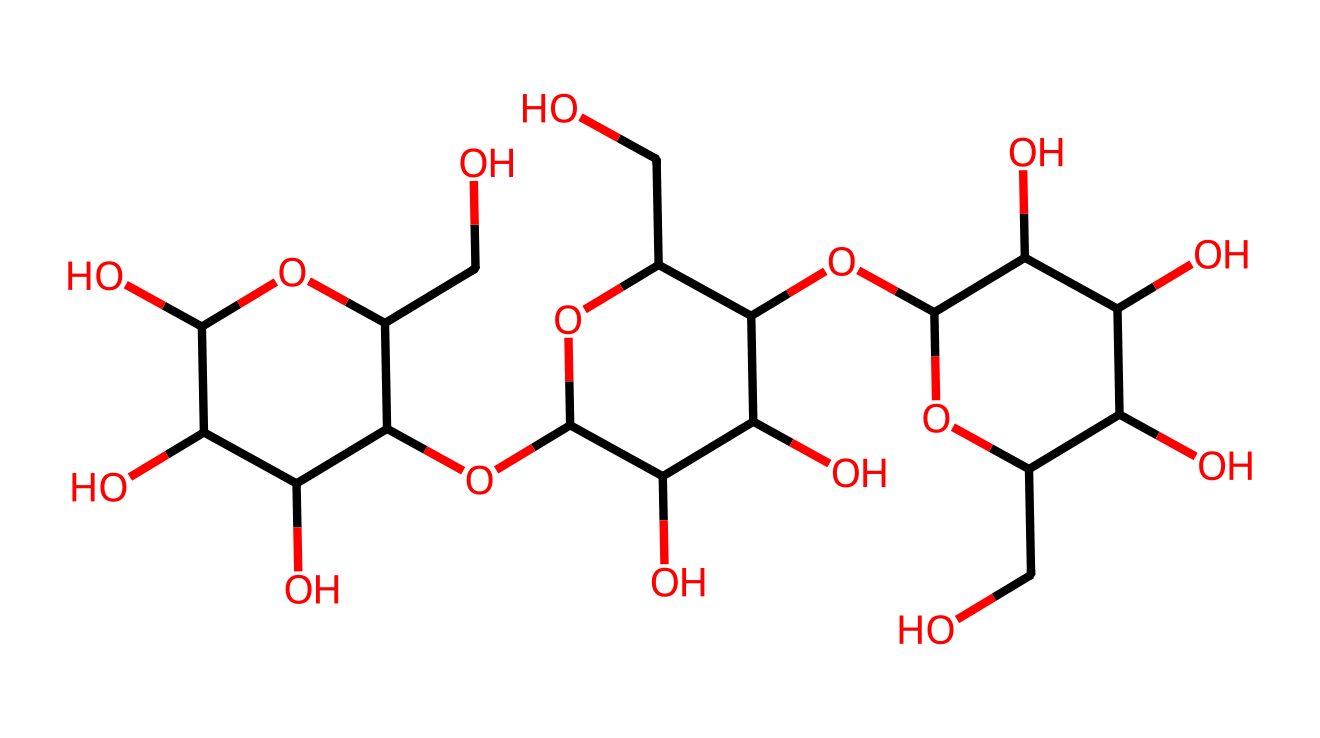How many carbon atoms are in the structure? To determine the number of carbon atoms, we can analyze the SMILES representation. Each "C" represents a carbon atom. By counting the occurrences of "C" in the SMILES string, we find there are a total of six carbon atoms.
Answer: six What type of compound is represented by this structure? This SMILES corresponds to a polysaccharide, specifically cellulose, which is made up of repeating glucose units. Cellulose is a complex carbohydrate representing a vital structural component in plant cell walls.
Answer: polysaccharide How many hydroxyl (–OH) groups are present? The hydroxyl groups are indicated by "O" that is attached to carbon atoms in the structure. By analyzing the SMILES representation, we can count the "O" atoms connected to carbon in the sugar unit, revealing that there are multiple –OH groups. In total, there are eight hydroxyl groups.
Answer: eight What is the degree of polymerization for this molecule? The degree of polymerization (DP) indicates how many monomeric units are present in the polymer chain. For cellulose, a common DP is indicative of multiple glucose monomers. By considering that glucose contributes one unit to the length, we can infer the structure includes multiple linked glucose units. The structure shows a high degree of polymerization, suggesting it is cellulose, commonly having DPs ranging from hundreds to thousands, but typically we consider it as more than 100 in this context.
Answer: high Can this molecule have geometric isomers? Geometric isomers typically arise from restricted rotation around a double bond or ring structure. However, considering that cellulose contains several stereogenic centers in the glucose units, it can technically exhibit various configurations, though in practice the term geometric isomers is usually not applied to polysaccharides. Nonetheless, the answer is yes; there are potential geometric isomers due to the multiple chiral centers.
Answer: yes 